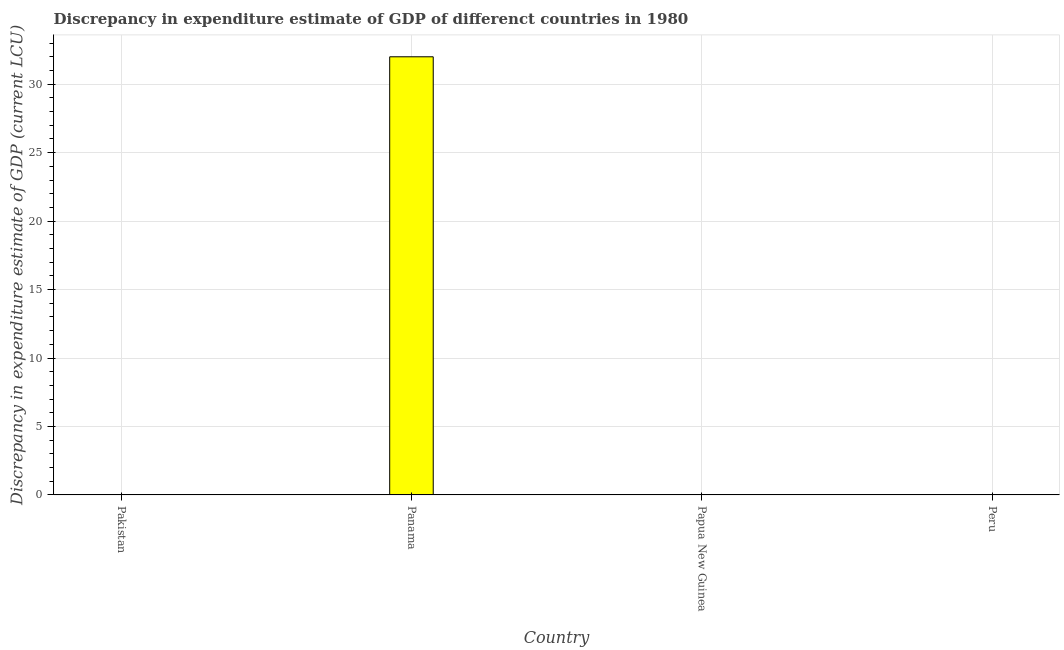What is the title of the graph?
Provide a succinct answer. Discrepancy in expenditure estimate of GDP of differenct countries in 1980. What is the label or title of the X-axis?
Your answer should be very brief. Country. What is the label or title of the Y-axis?
Provide a succinct answer. Discrepancy in expenditure estimate of GDP (current LCU). What is the discrepancy in expenditure estimate of gdp in Panama?
Provide a short and direct response. 32. Across all countries, what is the maximum discrepancy in expenditure estimate of gdp?
Your response must be concise. 32. In which country was the discrepancy in expenditure estimate of gdp maximum?
Give a very brief answer. Panama. What is the average discrepancy in expenditure estimate of gdp per country?
Provide a short and direct response. 8. What is the difference between the highest and the lowest discrepancy in expenditure estimate of gdp?
Make the answer very short. 32. How many bars are there?
Ensure brevity in your answer.  1. What is the difference between two consecutive major ticks on the Y-axis?
Offer a very short reply. 5. Are the values on the major ticks of Y-axis written in scientific E-notation?
Offer a very short reply. No. 